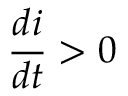<formula> <loc_0><loc_0><loc_500><loc_500>\frac { d i } { d t } > 0</formula> 